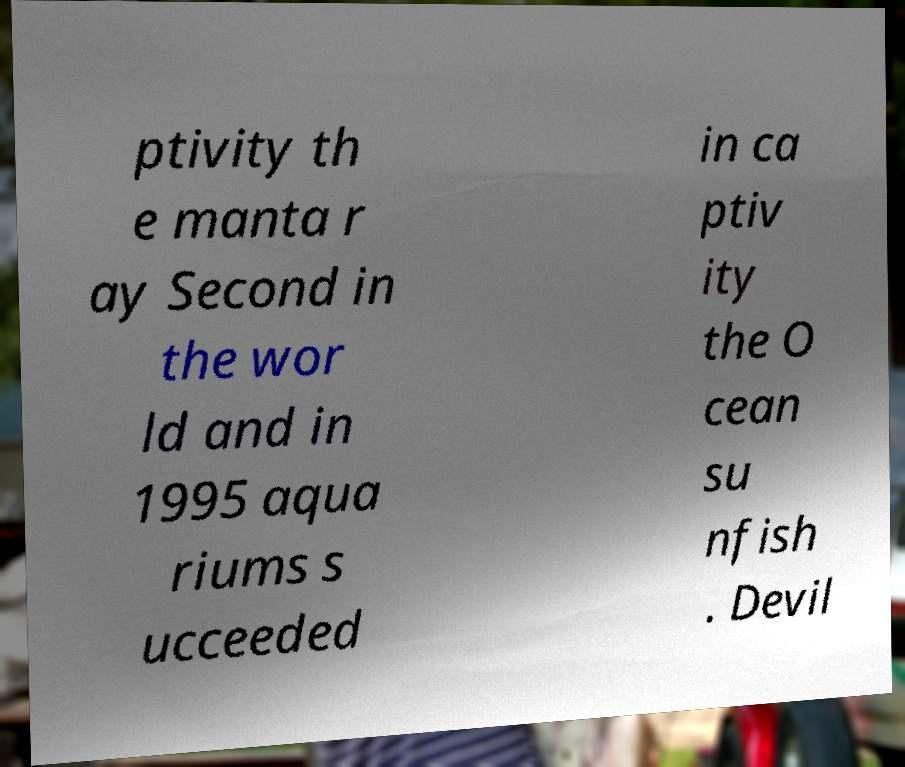Can you accurately transcribe the text from the provided image for me? ptivity th e manta r ay Second in the wor ld and in 1995 aqua riums s ucceeded in ca ptiv ity the O cean su nfish . Devil 